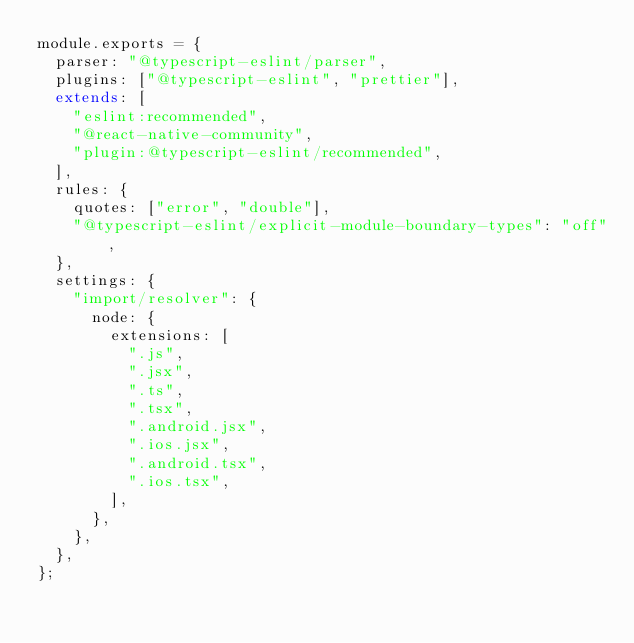Convert code to text. <code><loc_0><loc_0><loc_500><loc_500><_JavaScript_>module.exports = {
  parser: "@typescript-eslint/parser",
  plugins: ["@typescript-eslint", "prettier"],
  extends: [
    "eslint:recommended",
    "@react-native-community",
    "plugin:@typescript-eslint/recommended",
  ],
  rules: {
    quotes: ["error", "double"],
    "@typescript-eslint/explicit-module-boundary-types": "off",
  },
  settings: {
    "import/resolver": {
      node: {
        extensions: [
          ".js",
          ".jsx",
          ".ts",
          ".tsx",
          ".android.jsx",
          ".ios.jsx",
          ".android.tsx",
          ".ios.tsx",
        ],
      },
    },
  },
};
</code> 